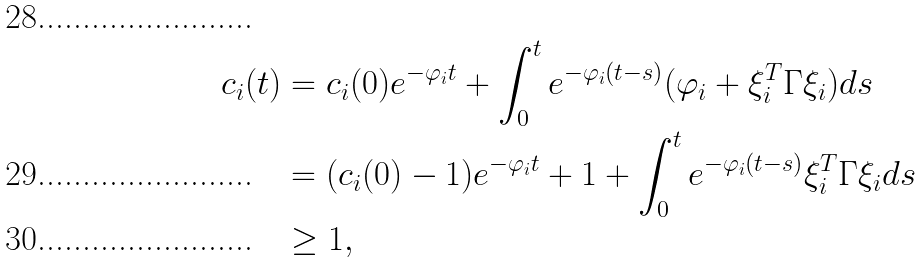<formula> <loc_0><loc_0><loc_500><loc_500>c _ { i } ( t ) & = c _ { i } ( 0 ) e ^ { - \varphi _ { i } t } + \int _ { 0 } ^ { t } e ^ { - \varphi _ { i } ( t - s ) } ( \varphi _ { i } + \xi _ { i } ^ { T } \Gamma \xi _ { i } ) d s \\ & = ( c _ { i } ( 0 ) - 1 ) e ^ { - \varphi _ { i } t } + 1 + \int _ { 0 } ^ { t } e ^ { - \varphi _ { i } ( t - s ) } \xi _ { i } ^ { T } \Gamma \xi _ { i } d s \\ & \geq 1 ,</formula> 